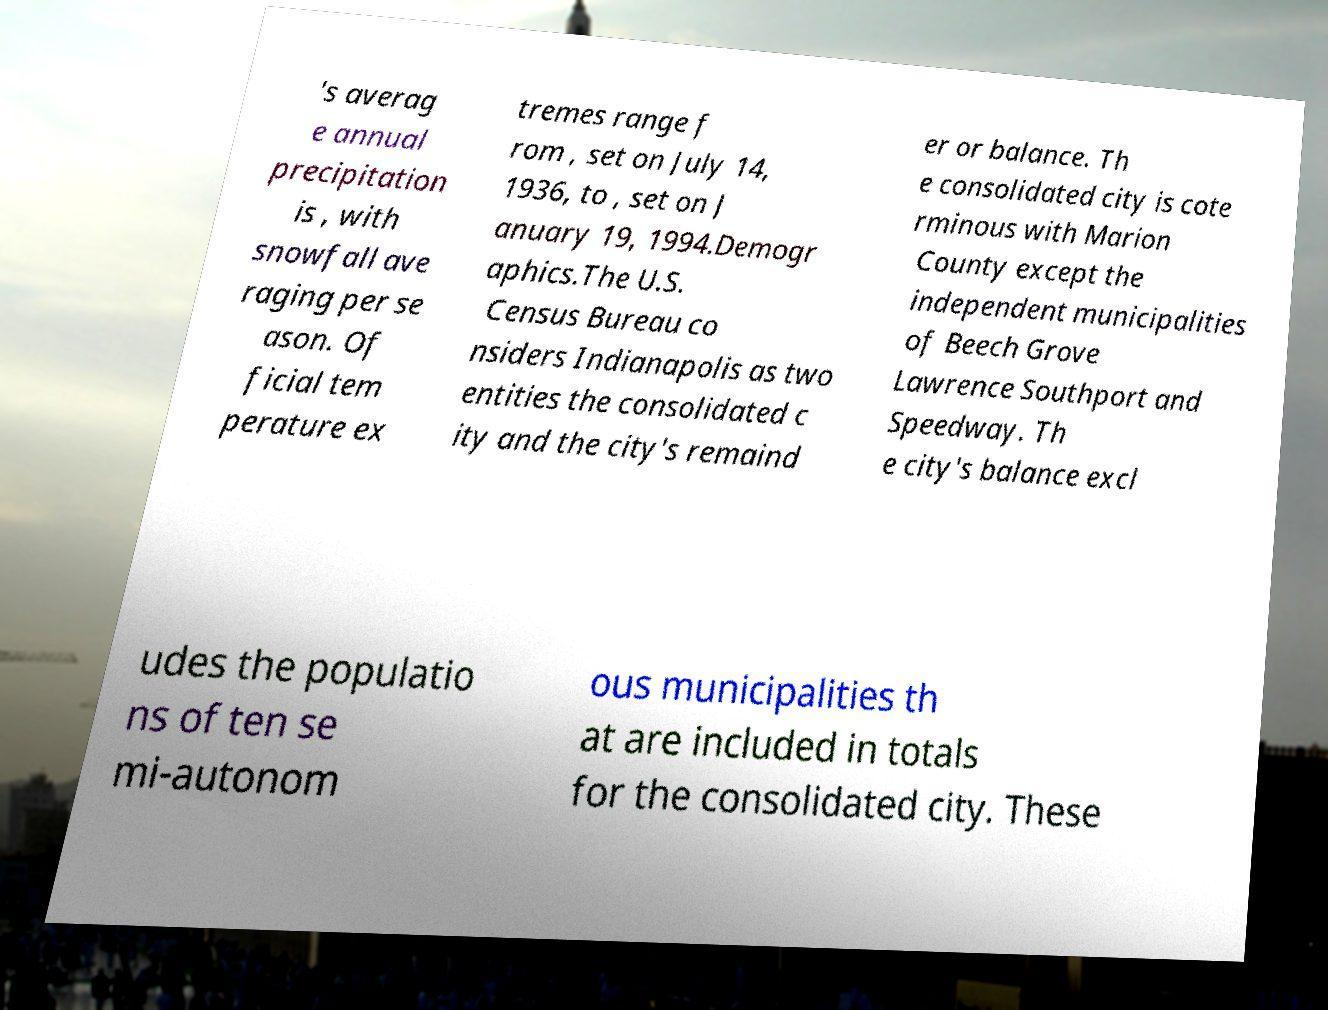Could you extract and type out the text from this image? 's averag e annual precipitation is , with snowfall ave raging per se ason. Of ficial tem perature ex tremes range f rom , set on July 14, 1936, to , set on J anuary 19, 1994.Demogr aphics.The U.S. Census Bureau co nsiders Indianapolis as two entities the consolidated c ity and the city's remaind er or balance. Th e consolidated city is cote rminous with Marion County except the independent municipalities of Beech Grove Lawrence Southport and Speedway. Th e city's balance excl udes the populatio ns of ten se mi-autonom ous municipalities th at are included in totals for the consolidated city. These 